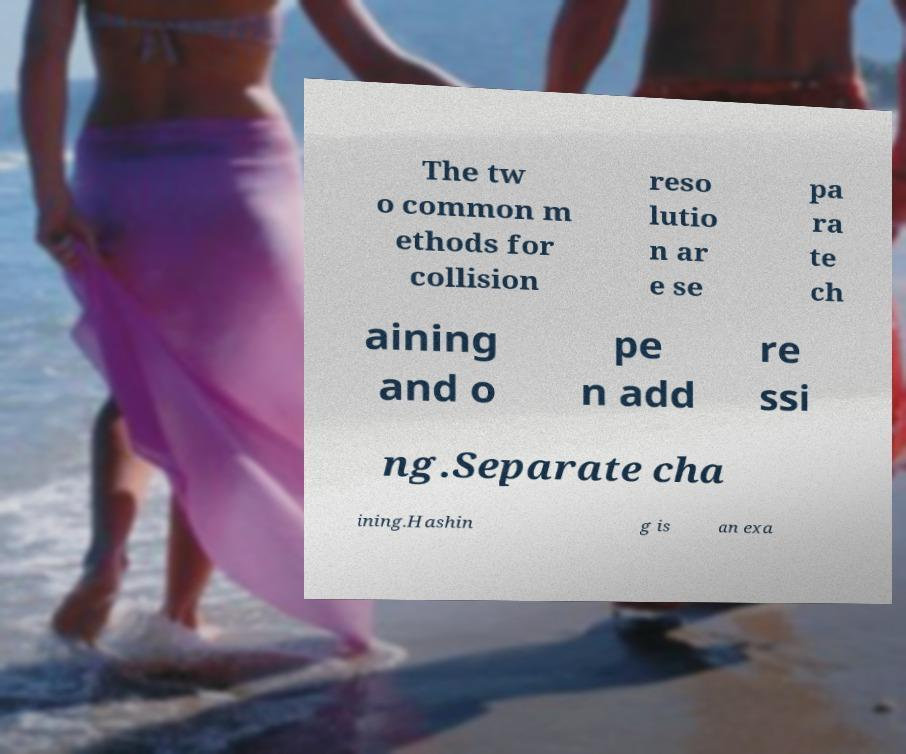For documentation purposes, I need the text within this image transcribed. Could you provide that? The tw o common m ethods for collision reso lutio n ar e se pa ra te ch aining and o pe n add re ssi ng.Separate cha ining.Hashin g is an exa 